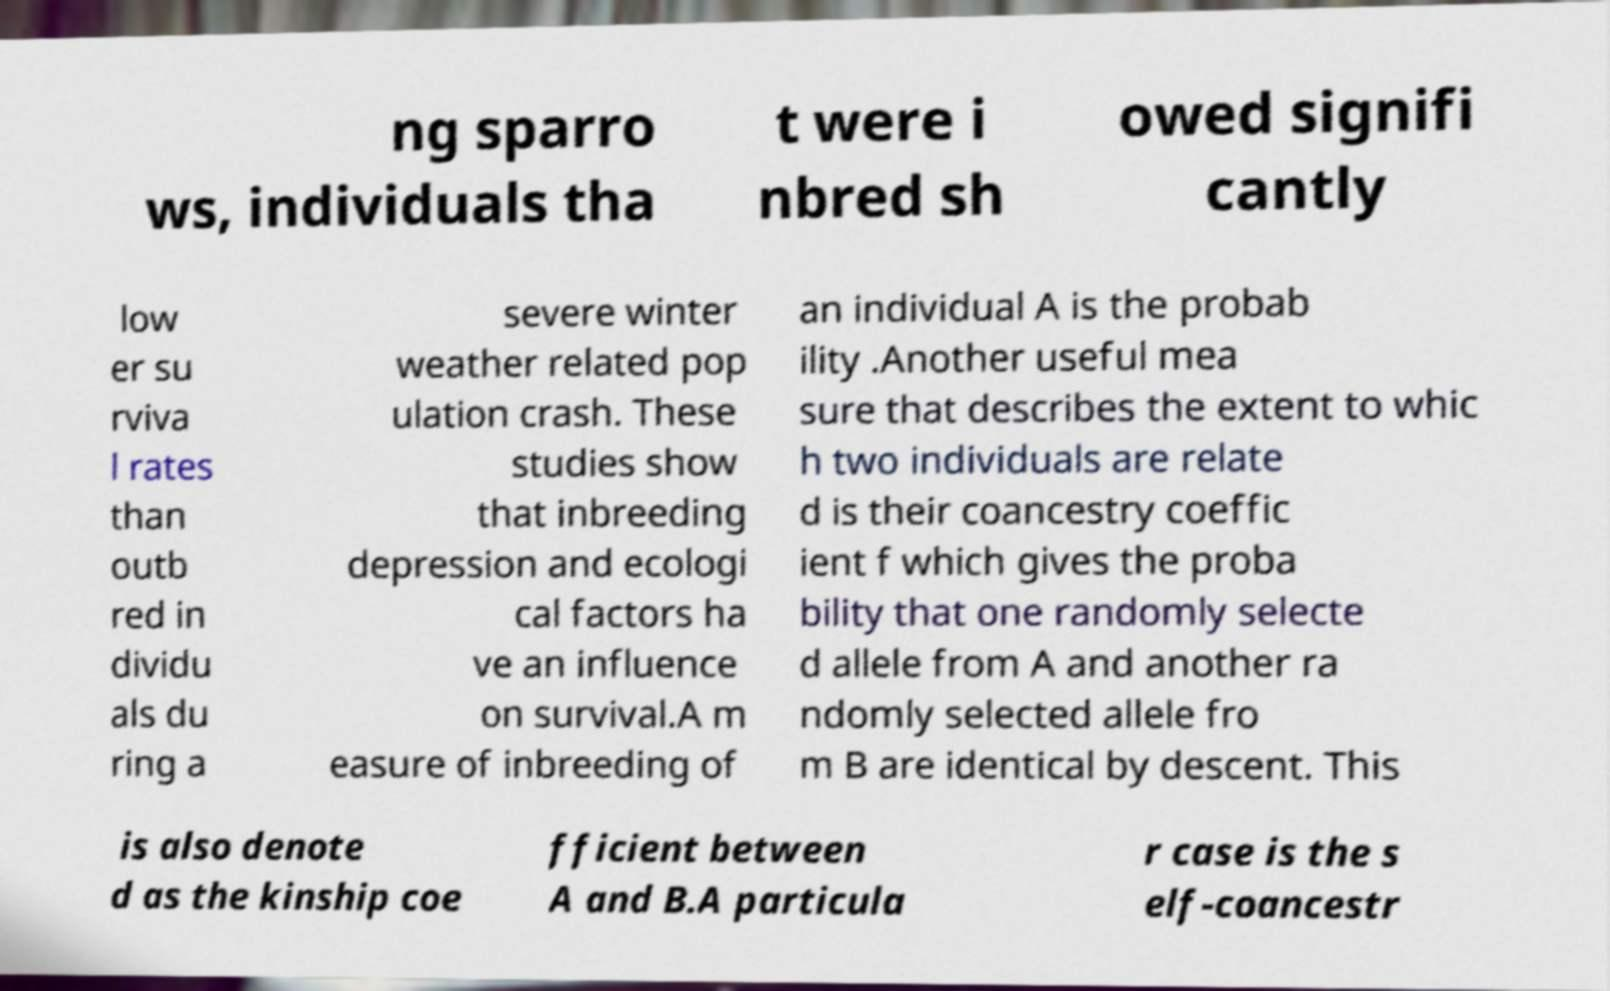Could you extract and type out the text from this image? ng sparro ws, individuals tha t were i nbred sh owed signifi cantly low er su rviva l rates than outb red in dividu als du ring a severe winter weather related pop ulation crash. These studies show that inbreeding depression and ecologi cal factors ha ve an influence on survival.A m easure of inbreeding of an individual A is the probab ility .Another useful mea sure that describes the extent to whic h two individuals are relate d is their coancestry coeffic ient f which gives the proba bility that one randomly selecte d allele from A and another ra ndomly selected allele fro m B are identical by descent. This is also denote d as the kinship coe fficient between A and B.A particula r case is the s elf-coancestr 